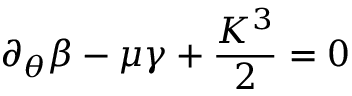Convert formula to latex. <formula><loc_0><loc_0><loc_500><loc_500>\partial _ { \theta } \beta - \mu \gamma + \frac { K ^ { 3 } } { 2 } = 0</formula> 